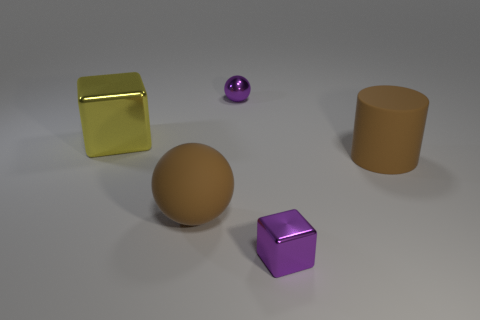Is there a cyan matte thing of the same size as the brown matte sphere?
Give a very brief answer. No. There is a brown cylinder that is the same size as the yellow cube; what material is it?
Offer a very short reply. Rubber. Do the cylinder and the shiny object that is left of the large brown matte ball have the same size?
Give a very brief answer. Yes. What number of metal things are purple objects or yellow things?
Give a very brief answer. 3. How many brown things are the same shape as the large yellow shiny thing?
Offer a very short reply. 0. What is the material of the sphere that is the same color as the cylinder?
Make the answer very short. Rubber. Does the purple object that is in front of the large ball have the same size as the purple metallic thing that is behind the yellow object?
Your answer should be compact. Yes. There is a purple shiny thing that is in front of the yellow metallic cube; what shape is it?
Your answer should be very brief. Cube. What material is the small thing that is the same shape as the large yellow object?
Provide a succinct answer. Metal. Do the brown matte thing on the right side of the purple block and the large metal block have the same size?
Make the answer very short. Yes. 